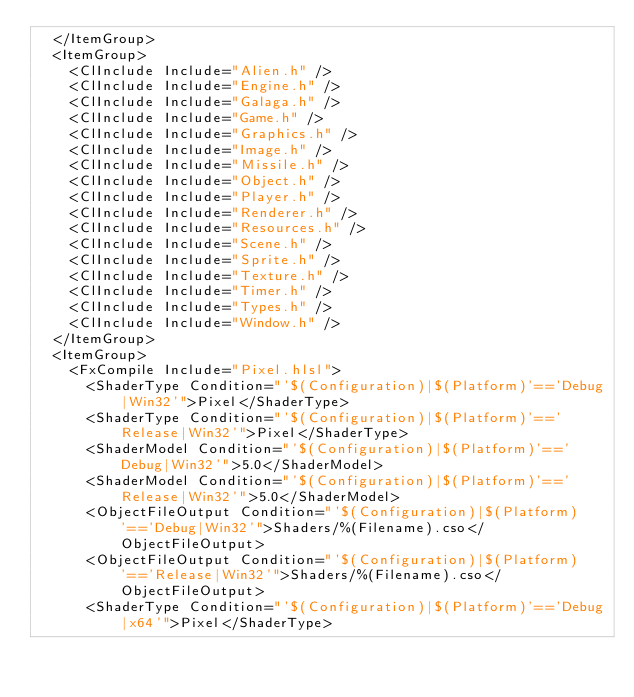<code> <loc_0><loc_0><loc_500><loc_500><_XML_>  </ItemGroup>
  <ItemGroup>
    <ClInclude Include="Alien.h" />
    <ClInclude Include="Engine.h" />
    <ClInclude Include="Galaga.h" />
    <ClInclude Include="Game.h" />
    <ClInclude Include="Graphics.h" />
    <ClInclude Include="Image.h" />
    <ClInclude Include="Missile.h" />
    <ClInclude Include="Object.h" />
    <ClInclude Include="Player.h" />
    <ClInclude Include="Renderer.h" />
    <ClInclude Include="Resources.h" />
    <ClInclude Include="Scene.h" />
    <ClInclude Include="Sprite.h" />
    <ClInclude Include="Texture.h" />
    <ClInclude Include="Timer.h" />
    <ClInclude Include="Types.h" />
    <ClInclude Include="Window.h" />
  </ItemGroup>
  <ItemGroup>
    <FxCompile Include="Pixel.hlsl">
      <ShaderType Condition="'$(Configuration)|$(Platform)'=='Debug|Win32'">Pixel</ShaderType>
      <ShaderType Condition="'$(Configuration)|$(Platform)'=='Release|Win32'">Pixel</ShaderType>
      <ShaderModel Condition="'$(Configuration)|$(Platform)'=='Debug|Win32'">5.0</ShaderModel>
      <ShaderModel Condition="'$(Configuration)|$(Platform)'=='Release|Win32'">5.0</ShaderModel>
      <ObjectFileOutput Condition="'$(Configuration)|$(Platform)'=='Debug|Win32'">Shaders/%(Filename).cso</ObjectFileOutput>
      <ObjectFileOutput Condition="'$(Configuration)|$(Platform)'=='Release|Win32'">Shaders/%(Filename).cso</ObjectFileOutput>
      <ShaderType Condition="'$(Configuration)|$(Platform)'=='Debug|x64'">Pixel</ShaderType></code> 